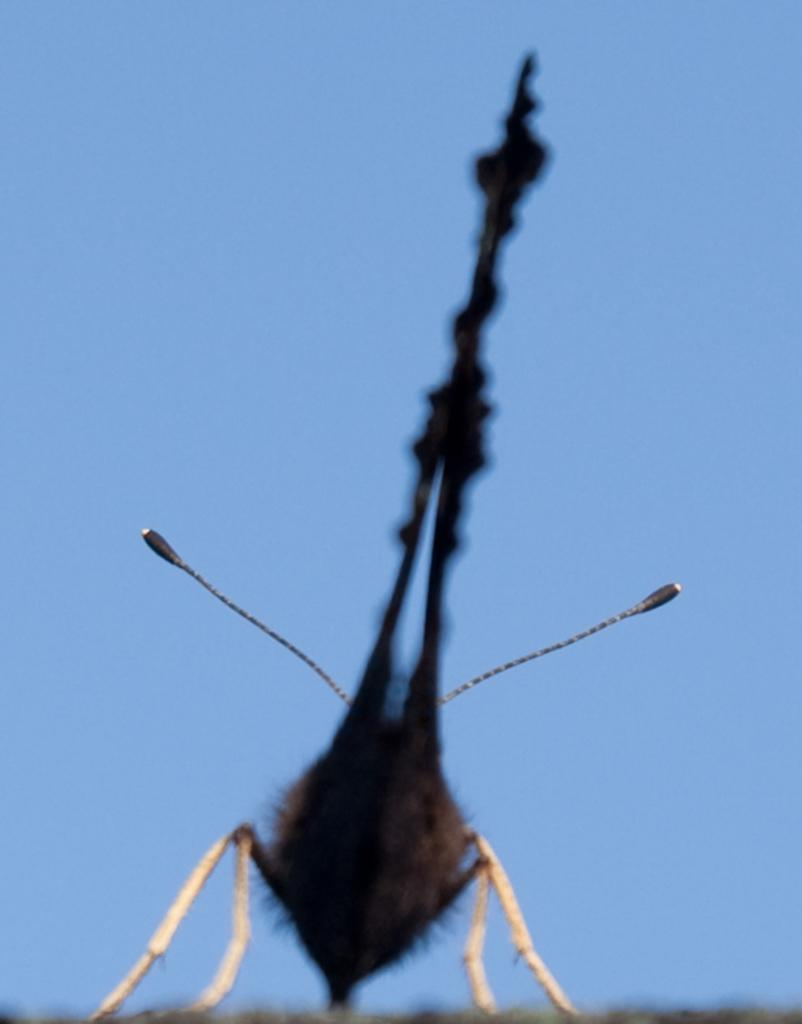What is located in the foreground of the image? There is an insect in the foreground of the image. What can be seen in the background of the image? The sky is visible in the background of the image. What type of underwear is the insect wearing in the image? Insects do not wear underwear, and there is no underwear present in the image. 